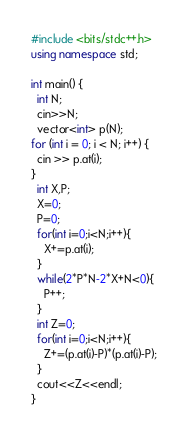Convert code to text. <code><loc_0><loc_0><loc_500><loc_500><_C++_>#include <bits/stdc++.h>
using namespace std;

int main() {
  int N;
  cin>>N;
  vector<int> p(N);
for (int i = 0; i < N; i++) {
  cin >> p.at(i);
}
  int X,P;
  X=0;
  P=0;
  for(int i=0;i<N;i++){
    X+=p.at(i);
  }
  while(2*P*N-2*X+N<0){
    P++;
  }
  int Z=0;
  for(int i=0;i<N;i++){
    Z+=(p.at(i)-P)*(p.at(i)-P);
  }
  cout<<Z<<endl;
}</code> 